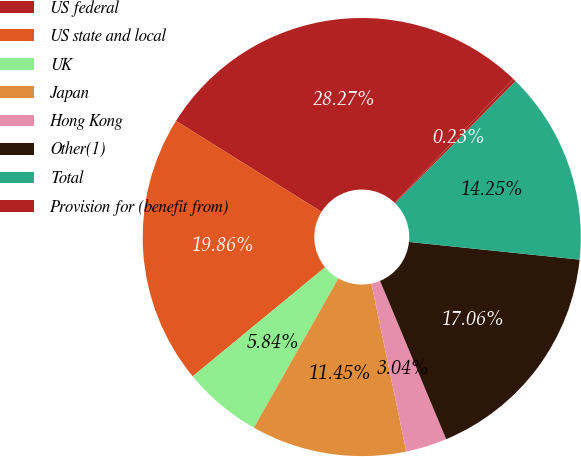Convert chart. <chart><loc_0><loc_0><loc_500><loc_500><pie_chart><fcel>US federal<fcel>US state and local<fcel>UK<fcel>Japan<fcel>Hong Kong<fcel>Other(1)<fcel>Total<fcel>Provision for (benefit from)<nl><fcel>28.27%<fcel>19.86%<fcel>5.84%<fcel>11.45%<fcel>3.04%<fcel>17.06%<fcel>14.25%<fcel>0.23%<nl></chart> 